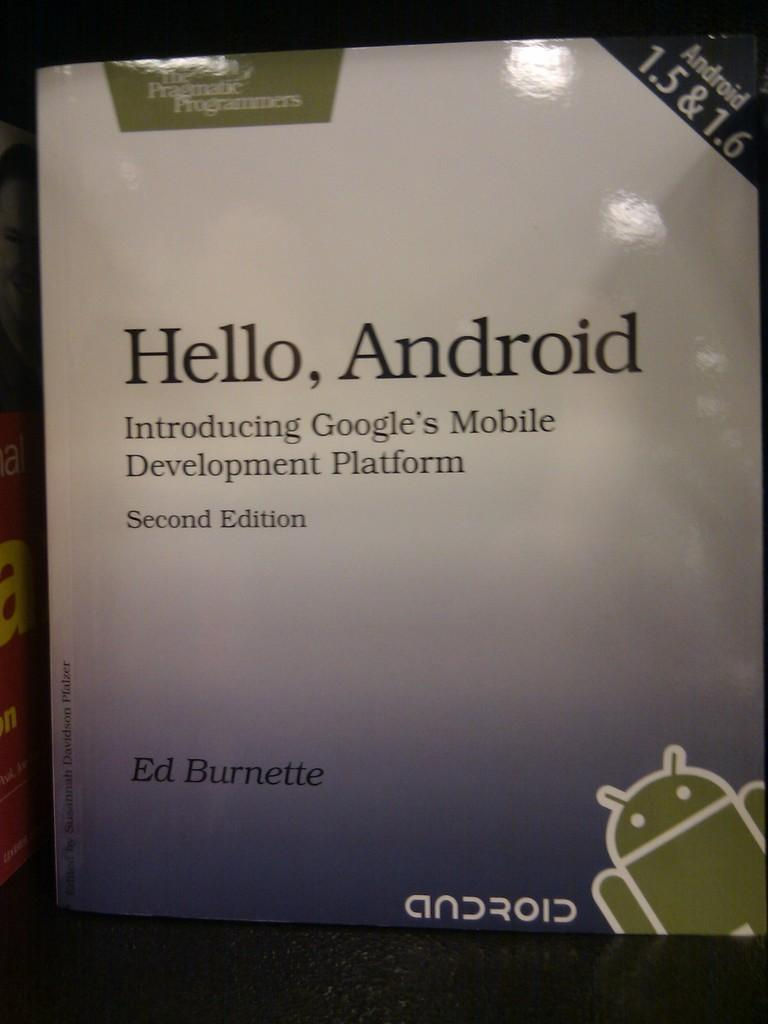<image>
Summarize the visual content of the image. Book cover saying "Hello,Android" on the cover by Ed Burnette. 